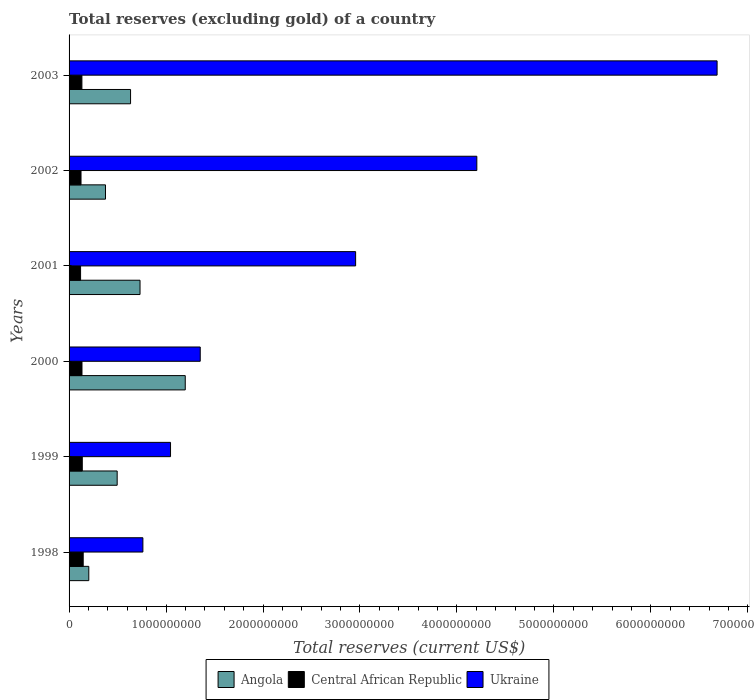How many different coloured bars are there?
Offer a very short reply. 3. How many groups of bars are there?
Your answer should be very brief. 6. Are the number of bars on each tick of the Y-axis equal?
Provide a short and direct response. Yes. How many bars are there on the 1st tick from the top?
Your answer should be very brief. 3. What is the label of the 4th group of bars from the top?
Your response must be concise. 2000. What is the total reserves (excluding gold) in Angola in 2002?
Make the answer very short. 3.76e+08. Across all years, what is the maximum total reserves (excluding gold) in Ukraine?
Ensure brevity in your answer.  6.68e+09. Across all years, what is the minimum total reserves (excluding gold) in Central African Republic?
Offer a terse response. 1.19e+08. In which year was the total reserves (excluding gold) in Angola minimum?
Keep it short and to the point. 1998. What is the total total reserves (excluding gold) in Angola in the graph?
Make the answer very short. 3.64e+09. What is the difference between the total reserves (excluding gold) in Central African Republic in 2001 and that in 2003?
Your answer should be very brief. -1.37e+07. What is the difference between the total reserves (excluding gold) in Central African Republic in 2000 and the total reserves (excluding gold) in Angola in 1999?
Offer a very short reply. -3.63e+08. What is the average total reserves (excluding gold) in Ukraine per year?
Provide a short and direct response. 2.83e+09. In the year 1998, what is the difference between the total reserves (excluding gold) in Ukraine and total reserves (excluding gold) in Central African Republic?
Provide a short and direct response. 6.16e+08. In how many years, is the total reserves (excluding gold) in Ukraine greater than 3800000000 US$?
Give a very brief answer. 2. What is the ratio of the total reserves (excluding gold) in Ukraine in 1999 to that in 2002?
Provide a succinct answer. 0.25. Is the total reserves (excluding gold) in Ukraine in 2000 less than that in 2002?
Keep it short and to the point. Yes. Is the difference between the total reserves (excluding gold) in Ukraine in 2000 and 2002 greater than the difference between the total reserves (excluding gold) in Central African Republic in 2000 and 2002?
Give a very brief answer. No. What is the difference between the highest and the second highest total reserves (excluding gold) in Angola?
Offer a terse response. 4.66e+08. What is the difference between the highest and the lowest total reserves (excluding gold) in Central African Republic?
Provide a short and direct response. 2.70e+07. Is the sum of the total reserves (excluding gold) in Ukraine in 1999 and 2003 greater than the maximum total reserves (excluding gold) in Central African Republic across all years?
Provide a succinct answer. Yes. What does the 3rd bar from the top in 1998 represents?
Offer a terse response. Angola. What does the 3rd bar from the bottom in 2000 represents?
Provide a short and direct response. Ukraine. Is it the case that in every year, the sum of the total reserves (excluding gold) in Ukraine and total reserves (excluding gold) in Central African Republic is greater than the total reserves (excluding gold) in Angola?
Provide a succinct answer. Yes. Are all the bars in the graph horizontal?
Provide a succinct answer. Yes. What is the difference between two consecutive major ticks on the X-axis?
Provide a succinct answer. 1.00e+09. Does the graph contain any zero values?
Provide a short and direct response. No. Does the graph contain grids?
Your response must be concise. No. Where does the legend appear in the graph?
Offer a terse response. Bottom center. How many legend labels are there?
Your response must be concise. 3. What is the title of the graph?
Give a very brief answer. Total reserves (excluding gold) of a country. Does "Libya" appear as one of the legend labels in the graph?
Your answer should be very brief. No. What is the label or title of the X-axis?
Keep it short and to the point. Total reserves (current US$). What is the Total reserves (current US$) of Angola in 1998?
Your answer should be very brief. 2.03e+08. What is the Total reserves (current US$) in Central African Republic in 1998?
Your answer should be very brief. 1.46e+08. What is the Total reserves (current US$) of Ukraine in 1998?
Provide a succinct answer. 7.61e+08. What is the Total reserves (current US$) in Angola in 1999?
Keep it short and to the point. 4.96e+08. What is the Total reserves (current US$) of Central African Republic in 1999?
Provide a short and direct response. 1.36e+08. What is the Total reserves (current US$) in Ukraine in 1999?
Ensure brevity in your answer.  1.05e+09. What is the Total reserves (current US$) in Angola in 2000?
Provide a succinct answer. 1.20e+09. What is the Total reserves (current US$) of Central African Republic in 2000?
Offer a very short reply. 1.33e+08. What is the Total reserves (current US$) in Ukraine in 2000?
Your answer should be very brief. 1.35e+09. What is the Total reserves (current US$) in Angola in 2001?
Ensure brevity in your answer.  7.32e+08. What is the Total reserves (current US$) of Central African Republic in 2001?
Your response must be concise. 1.19e+08. What is the Total reserves (current US$) in Ukraine in 2001?
Provide a short and direct response. 2.96e+09. What is the Total reserves (current US$) of Angola in 2002?
Your answer should be very brief. 3.76e+08. What is the Total reserves (current US$) in Central African Republic in 2002?
Keep it short and to the point. 1.23e+08. What is the Total reserves (current US$) of Ukraine in 2002?
Provide a succinct answer. 4.21e+09. What is the Total reserves (current US$) of Angola in 2003?
Your answer should be compact. 6.34e+08. What is the Total reserves (current US$) of Central African Republic in 2003?
Keep it short and to the point. 1.32e+08. What is the Total reserves (current US$) of Ukraine in 2003?
Keep it short and to the point. 6.68e+09. Across all years, what is the maximum Total reserves (current US$) in Angola?
Your answer should be very brief. 1.20e+09. Across all years, what is the maximum Total reserves (current US$) in Central African Republic?
Your answer should be very brief. 1.46e+08. Across all years, what is the maximum Total reserves (current US$) in Ukraine?
Ensure brevity in your answer.  6.68e+09. Across all years, what is the minimum Total reserves (current US$) of Angola?
Your answer should be very brief. 2.03e+08. Across all years, what is the minimum Total reserves (current US$) of Central African Republic?
Your response must be concise. 1.19e+08. Across all years, what is the minimum Total reserves (current US$) in Ukraine?
Give a very brief answer. 7.61e+08. What is the total Total reserves (current US$) in Angola in the graph?
Provide a succinct answer. 3.64e+09. What is the total Total reserves (current US$) in Central African Republic in the graph?
Your answer should be compact. 7.90e+08. What is the total Total reserves (current US$) in Ukraine in the graph?
Provide a succinct answer. 1.70e+1. What is the difference between the Total reserves (current US$) of Angola in 1998 and that in 1999?
Provide a short and direct response. -2.93e+08. What is the difference between the Total reserves (current US$) of Central African Republic in 1998 and that in 1999?
Make the answer very short. 9.42e+06. What is the difference between the Total reserves (current US$) of Ukraine in 1998 and that in 1999?
Offer a very short reply. -2.85e+08. What is the difference between the Total reserves (current US$) of Angola in 1998 and that in 2000?
Your answer should be compact. -9.95e+08. What is the difference between the Total reserves (current US$) of Central African Republic in 1998 and that in 2000?
Offer a terse response. 1.24e+07. What is the difference between the Total reserves (current US$) in Ukraine in 1998 and that in 2000?
Your answer should be compact. -5.91e+08. What is the difference between the Total reserves (current US$) in Angola in 1998 and that in 2001?
Your response must be concise. -5.28e+08. What is the difference between the Total reserves (current US$) of Central African Republic in 1998 and that in 2001?
Offer a terse response. 2.70e+07. What is the difference between the Total reserves (current US$) of Ukraine in 1998 and that in 2001?
Make the answer very short. -2.19e+09. What is the difference between the Total reserves (current US$) of Angola in 1998 and that in 2002?
Provide a succinct answer. -1.72e+08. What is the difference between the Total reserves (current US$) in Central African Republic in 1998 and that in 2002?
Offer a terse response. 2.25e+07. What is the difference between the Total reserves (current US$) in Ukraine in 1998 and that in 2002?
Keep it short and to the point. -3.44e+09. What is the difference between the Total reserves (current US$) in Angola in 1998 and that in 2003?
Ensure brevity in your answer.  -4.31e+08. What is the difference between the Total reserves (current US$) of Central African Republic in 1998 and that in 2003?
Make the answer very short. 1.33e+07. What is the difference between the Total reserves (current US$) of Ukraine in 1998 and that in 2003?
Your response must be concise. -5.92e+09. What is the difference between the Total reserves (current US$) of Angola in 1999 and that in 2000?
Give a very brief answer. -7.02e+08. What is the difference between the Total reserves (current US$) in Central African Republic in 1999 and that in 2000?
Your response must be concise. 3.02e+06. What is the difference between the Total reserves (current US$) in Ukraine in 1999 and that in 2000?
Offer a very short reply. -3.06e+08. What is the difference between the Total reserves (current US$) in Angola in 1999 and that in 2001?
Provide a short and direct response. -2.36e+08. What is the difference between the Total reserves (current US$) in Central African Republic in 1999 and that in 2001?
Give a very brief answer. 1.75e+07. What is the difference between the Total reserves (current US$) in Ukraine in 1999 and that in 2001?
Keep it short and to the point. -1.91e+09. What is the difference between the Total reserves (current US$) of Angola in 1999 and that in 2002?
Your answer should be compact. 1.21e+08. What is the difference between the Total reserves (current US$) in Central African Republic in 1999 and that in 2002?
Offer a very short reply. 1.30e+07. What is the difference between the Total reserves (current US$) in Ukraine in 1999 and that in 2002?
Keep it short and to the point. -3.16e+09. What is the difference between the Total reserves (current US$) of Angola in 1999 and that in 2003?
Provide a short and direct response. -1.38e+08. What is the difference between the Total reserves (current US$) in Central African Republic in 1999 and that in 2003?
Your answer should be very brief. 3.87e+06. What is the difference between the Total reserves (current US$) of Ukraine in 1999 and that in 2003?
Give a very brief answer. -5.64e+09. What is the difference between the Total reserves (current US$) of Angola in 2000 and that in 2001?
Ensure brevity in your answer.  4.66e+08. What is the difference between the Total reserves (current US$) in Central African Republic in 2000 and that in 2001?
Provide a succinct answer. 1.45e+07. What is the difference between the Total reserves (current US$) in Ukraine in 2000 and that in 2001?
Keep it short and to the point. -1.60e+09. What is the difference between the Total reserves (current US$) in Angola in 2000 and that in 2002?
Make the answer very short. 8.23e+08. What is the difference between the Total reserves (current US$) in Central African Republic in 2000 and that in 2002?
Your answer should be very brief. 1.00e+07. What is the difference between the Total reserves (current US$) in Ukraine in 2000 and that in 2002?
Keep it short and to the point. -2.85e+09. What is the difference between the Total reserves (current US$) of Angola in 2000 and that in 2003?
Ensure brevity in your answer.  5.64e+08. What is the difference between the Total reserves (current US$) in Central African Republic in 2000 and that in 2003?
Provide a short and direct response. 8.47e+05. What is the difference between the Total reserves (current US$) in Ukraine in 2000 and that in 2003?
Keep it short and to the point. -5.33e+09. What is the difference between the Total reserves (current US$) in Angola in 2001 and that in 2002?
Your answer should be very brief. 3.56e+08. What is the difference between the Total reserves (current US$) of Central African Republic in 2001 and that in 2002?
Make the answer very short. -4.49e+06. What is the difference between the Total reserves (current US$) in Ukraine in 2001 and that in 2002?
Your response must be concise. -1.25e+09. What is the difference between the Total reserves (current US$) of Angola in 2001 and that in 2003?
Give a very brief answer. 9.77e+07. What is the difference between the Total reserves (current US$) in Central African Republic in 2001 and that in 2003?
Give a very brief answer. -1.37e+07. What is the difference between the Total reserves (current US$) of Ukraine in 2001 and that in 2003?
Provide a short and direct response. -3.73e+09. What is the difference between the Total reserves (current US$) in Angola in 2002 and that in 2003?
Give a very brief answer. -2.59e+08. What is the difference between the Total reserves (current US$) in Central African Republic in 2002 and that in 2003?
Provide a succinct answer. -9.17e+06. What is the difference between the Total reserves (current US$) of Ukraine in 2002 and that in 2003?
Give a very brief answer. -2.48e+09. What is the difference between the Total reserves (current US$) of Angola in 1998 and the Total reserves (current US$) of Central African Republic in 1999?
Ensure brevity in your answer.  6.72e+07. What is the difference between the Total reserves (current US$) in Angola in 1998 and the Total reserves (current US$) in Ukraine in 1999?
Provide a succinct answer. -8.43e+08. What is the difference between the Total reserves (current US$) of Central African Republic in 1998 and the Total reserves (current US$) of Ukraine in 1999?
Offer a very short reply. -9.01e+08. What is the difference between the Total reserves (current US$) of Angola in 1998 and the Total reserves (current US$) of Central African Republic in 2000?
Give a very brief answer. 7.02e+07. What is the difference between the Total reserves (current US$) in Angola in 1998 and the Total reserves (current US$) in Ukraine in 2000?
Offer a very short reply. -1.15e+09. What is the difference between the Total reserves (current US$) of Central African Republic in 1998 and the Total reserves (current US$) of Ukraine in 2000?
Make the answer very short. -1.21e+09. What is the difference between the Total reserves (current US$) of Angola in 1998 and the Total reserves (current US$) of Central African Republic in 2001?
Your answer should be very brief. 8.47e+07. What is the difference between the Total reserves (current US$) of Angola in 1998 and the Total reserves (current US$) of Ukraine in 2001?
Ensure brevity in your answer.  -2.75e+09. What is the difference between the Total reserves (current US$) of Central African Republic in 1998 and the Total reserves (current US$) of Ukraine in 2001?
Make the answer very short. -2.81e+09. What is the difference between the Total reserves (current US$) of Angola in 1998 and the Total reserves (current US$) of Central African Republic in 2002?
Make the answer very short. 8.02e+07. What is the difference between the Total reserves (current US$) in Angola in 1998 and the Total reserves (current US$) in Ukraine in 2002?
Offer a terse response. -4.00e+09. What is the difference between the Total reserves (current US$) of Central African Republic in 1998 and the Total reserves (current US$) of Ukraine in 2002?
Offer a terse response. -4.06e+09. What is the difference between the Total reserves (current US$) of Angola in 1998 and the Total reserves (current US$) of Central African Republic in 2003?
Give a very brief answer. 7.10e+07. What is the difference between the Total reserves (current US$) in Angola in 1998 and the Total reserves (current US$) in Ukraine in 2003?
Give a very brief answer. -6.48e+09. What is the difference between the Total reserves (current US$) of Central African Republic in 1998 and the Total reserves (current US$) of Ukraine in 2003?
Provide a succinct answer. -6.54e+09. What is the difference between the Total reserves (current US$) in Angola in 1999 and the Total reserves (current US$) in Central African Republic in 2000?
Your response must be concise. 3.63e+08. What is the difference between the Total reserves (current US$) of Angola in 1999 and the Total reserves (current US$) of Ukraine in 2000?
Your answer should be very brief. -8.57e+08. What is the difference between the Total reserves (current US$) in Central African Republic in 1999 and the Total reserves (current US$) in Ukraine in 2000?
Keep it short and to the point. -1.22e+09. What is the difference between the Total reserves (current US$) in Angola in 1999 and the Total reserves (current US$) in Central African Republic in 2001?
Give a very brief answer. 3.77e+08. What is the difference between the Total reserves (current US$) in Angola in 1999 and the Total reserves (current US$) in Ukraine in 2001?
Give a very brief answer. -2.46e+09. What is the difference between the Total reserves (current US$) of Central African Republic in 1999 and the Total reserves (current US$) of Ukraine in 2001?
Your answer should be compact. -2.82e+09. What is the difference between the Total reserves (current US$) in Angola in 1999 and the Total reserves (current US$) in Central African Republic in 2002?
Your answer should be very brief. 3.73e+08. What is the difference between the Total reserves (current US$) in Angola in 1999 and the Total reserves (current US$) in Ukraine in 2002?
Offer a terse response. -3.71e+09. What is the difference between the Total reserves (current US$) in Central African Republic in 1999 and the Total reserves (current US$) in Ukraine in 2002?
Ensure brevity in your answer.  -4.07e+09. What is the difference between the Total reserves (current US$) of Angola in 1999 and the Total reserves (current US$) of Central African Republic in 2003?
Your answer should be very brief. 3.64e+08. What is the difference between the Total reserves (current US$) of Angola in 1999 and the Total reserves (current US$) of Ukraine in 2003?
Keep it short and to the point. -6.19e+09. What is the difference between the Total reserves (current US$) in Central African Republic in 1999 and the Total reserves (current US$) in Ukraine in 2003?
Provide a short and direct response. -6.55e+09. What is the difference between the Total reserves (current US$) in Angola in 2000 and the Total reserves (current US$) in Central African Republic in 2001?
Your answer should be very brief. 1.08e+09. What is the difference between the Total reserves (current US$) of Angola in 2000 and the Total reserves (current US$) of Ukraine in 2001?
Your response must be concise. -1.76e+09. What is the difference between the Total reserves (current US$) in Central African Republic in 2000 and the Total reserves (current US$) in Ukraine in 2001?
Your answer should be compact. -2.82e+09. What is the difference between the Total reserves (current US$) of Angola in 2000 and the Total reserves (current US$) of Central African Republic in 2002?
Offer a terse response. 1.07e+09. What is the difference between the Total reserves (current US$) in Angola in 2000 and the Total reserves (current US$) in Ukraine in 2002?
Keep it short and to the point. -3.01e+09. What is the difference between the Total reserves (current US$) of Central African Republic in 2000 and the Total reserves (current US$) of Ukraine in 2002?
Offer a terse response. -4.07e+09. What is the difference between the Total reserves (current US$) in Angola in 2000 and the Total reserves (current US$) in Central African Republic in 2003?
Give a very brief answer. 1.07e+09. What is the difference between the Total reserves (current US$) in Angola in 2000 and the Total reserves (current US$) in Ukraine in 2003?
Your response must be concise. -5.48e+09. What is the difference between the Total reserves (current US$) in Central African Republic in 2000 and the Total reserves (current US$) in Ukraine in 2003?
Your answer should be very brief. -6.55e+09. What is the difference between the Total reserves (current US$) in Angola in 2001 and the Total reserves (current US$) in Central African Republic in 2002?
Offer a very short reply. 6.09e+08. What is the difference between the Total reserves (current US$) of Angola in 2001 and the Total reserves (current US$) of Ukraine in 2002?
Ensure brevity in your answer.  -3.47e+09. What is the difference between the Total reserves (current US$) of Central African Republic in 2001 and the Total reserves (current US$) of Ukraine in 2002?
Keep it short and to the point. -4.09e+09. What is the difference between the Total reserves (current US$) of Angola in 2001 and the Total reserves (current US$) of Central African Republic in 2003?
Make the answer very short. 5.99e+08. What is the difference between the Total reserves (current US$) in Angola in 2001 and the Total reserves (current US$) in Ukraine in 2003?
Provide a succinct answer. -5.95e+09. What is the difference between the Total reserves (current US$) of Central African Republic in 2001 and the Total reserves (current US$) of Ukraine in 2003?
Make the answer very short. -6.56e+09. What is the difference between the Total reserves (current US$) of Angola in 2002 and the Total reserves (current US$) of Central African Republic in 2003?
Your answer should be very brief. 2.43e+08. What is the difference between the Total reserves (current US$) in Angola in 2002 and the Total reserves (current US$) in Ukraine in 2003?
Make the answer very short. -6.31e+09. What is the difference between the Total reserves (current US$) of Central African Republic in 2002 and the Total reserves (current US$) of Ukraine in 2003?
Your response must be concise. -6.56e+09. What is the average Total reserves (current US$) in Angola per year?
Offer a terse response. 6.07e+08. What is the average Total reserves (current US$) of Central African Republic per year?
Your response must be concise. 1.32e+08. What is the average Total reserves (current US$) in Ukraine per year?
Your answer should be very brief. 2.83e+09. In the year 1998, what is the difference between the Total reserves (current US$) of Angola and Total reserves (current US$) of Central African Republic?
Offer a very short reply. 5.78e+07. In the year 1998, what is the difference between the Total reserves (current US$) of Angola and Total reserves (current US$) of Ukraine?
Make the answer very short. -5.58e+08. In the year 1998, what is the difference between the Total reserves (current US$) in Central African Republic and Total reserves (current US$) in Ukraine?
Your answer should be compact. -6.16e+08. In the year 1999, what is the difference between the Total reserves (current US$) in Angola and Total reserves (current US$) in Central African Republic?
Provide a succinct answer. 3.60e+08. In the year 1999, what is the difference between the Total reserves (current US$) in Angola and Total reserves (current US$) in Ukraine?
Provide a short and direct response. -5.50e+08. In the year 1999, what is the difference between the Total reserves (current US$) of Central African Republic and Total reserves (current US$) of Ukraine?
Your answer should be very brief. -9.10e+08. In the year 2000, what is the difference between the Total reserves (current US$) in Angola and Total reserves (current US$) in Central African Republic?
Offer a very short reply. 1.06e+09. In the year 2000, what is the difference between the Total reserves (current US$) of Angola and Total reserves (current US$) of Ukraine?
Offer a very short reply. -1.54e+08. In the year 2000, what is the difference between the Total reserves (current US$) of Central African Republic and Total reserves (current US$) of Ukraine?
Your response must be concise. -1.22e+09. In the year 2001, what is the difference between the Total reserves (current US$) of Angola and Total reserves (current US$) of Central African Republic?
Keep it short and to the point. 6.13e+08. In the year 2001, what is the difference between the Total reserves (current US$) in Angola and Total reserves (current US$) in Ukraine?
Provide a succinct answer. -2.22e+09. In the year 2001, what is the difference between the Total reserves (current US$) of Central African Republic and Total reserves (current US$) of Ukraine?
Provide a succinct answer. -2.84e+09. In the year 2002, what is the difference between the Total reserves (current US$) in Angola and Total reserves (current US$) in Central African Republic?
Provide a succinct answer. 2.52e+08. In the year 2002, what is the difference between the Total reserves (current US$) of Angola and Total reserves (current US$) of Ukraine?
Give a very brief answer. -3.83e+09. In the year 2002, what is the difference between the Total reserves (current US$) of Central African Republic and Total reserves (current US$) of Ukraine?
Provide a succinct answer. -4.08e+09. In the year 2003, what is the difference between the Total reserves (current US$) in Angola and Total reserves (current US$) in Central African Republic?
Offer a terse response. 5.02e+08. In the year 2003, what is the difference between the Total reserves (current US$) in Angola and Total reserves (current US$) in Ukraine?
Offer a very short reply. -6.05e+09. In the year 2003, what is the difference between the Total reserves (current US$) of Central African Republic and Total reserves (current US$) of Ukraine?
Ensure brevity in your answer.  -6.55e+09. What is the ratio of the Total reserves (current US$) in Angola in 1998 to that in 1999?
Your response must be concise. 0.41. What is the ratio of the Total reserves (current US$) of Central African Republic in 1998 to that in 1999?
Ensure brevity in your answer.  1.07. What is the ratio of the Total reserves (current US$) of Ukraine in 1998 to that in 1999?
Your response must be concise. 0.73. What is the ratio of the Total reserves (current US$) in Angola in 1998 to that in 2000?
Provide a succinct answer. 0.17. What is the ratio of the Total reserves (current US$) in Central African Republic in 1998 to that in 2000?
Provide a short and direct response. 1.09. What is the ratio of the Total reserves (current US$) in Ukraine in 1998 to that in 2000?
Offer a terse response. 0.56. What is the ratio of the Total reserves (current US$) of Angola in 1998 to that in 2001?
Ensure brevity in your answer.  0.28. What is the ratio of the Total reserves (current US$) of Central African Republic in 1998 to that in 2001?
Your answer should be very brief. 1.23. What is the ratio of the Total reserves (current US$) in Ukraine in 1998 to that in 2001?
Keep it short and to the point. 0.26. What is the ratio of the Total reserves (current US$) of Angola in 1998 to that in 2002?
Provide a succinct answer. 0.54. What is the ratio of the Total reserves (current US$) of Central African Republic in 1998 to that in 2002?
Your response must be concise. 1.18. What is the ratio of the Total reserves (current US$) of Ukraine in 1998 to that in 2002?
Keep it short and to the point. 0.18. What is the ratio of the Total reserves (current US$) of Angola in 1998 to that in 2003?
Provide a succinct answer. 0.32. What is the ratio of the Total reserves (current US$) in Central African Republic in 1998 to that in 2003?
Give a very brief answer. 1.1. What is the ratio of the Total reserves (current US$) of Ukraine in 1998 to that in 2003?
Ensure brevity in your answer.  0.11. What is the ratio of the Total reserves (current US$) in Angola in 1999 to that in 2000?
Your response must be concise. 0.41. What is the ratio of the Total reserves (current US$) in Central African Republic in 1999 to that in 2000?
Offer a very short reply. 1.02. What is the ratio of the Total reserves (current US$) of Ukraine in 1999 to that in 2000?
Make the answer very short. 0.77. What is the ratio of the Total reserves (current US$) of Angola in 1999 to that in 2001?
Provide a short and direct response. 0.68. What is the ratio of the Total reserves (current US$) of Central African Republic in 1999 to that in 2001?
Give a very brief answer. 1.15. What is the ratio of the Total reserves (current US$) in Ukraine in 1999 to that in 2001?
Your answer should be compact. 0.35. What is the ratio of the Total reserves (current US$) in Angola in 1999 to that in 2002?
Ensure brevity in your answer.  1.32. What is the ratio of the Total reserves (current US$) in Central African Republic in 1999 to that in 2002?
Your answer should be very brief. 1.11. What is the ratio of the Total reserves (current US$) of Ukraine in 1999 to that in 2002?
Your answer should be compact. 0.25. What is the ratio of the Total reserves (current US$) of Angola in 1999 to that in 2003?
Offer a very short reply. 0.78. What is the ratio of the Total reserves (current US$) in Central African Republic in 1999 to that in 2003?
Your answer should be very brief. 1.03. What is the ratio of the Total reserves (current US$) in Ukraine in 1999 to that in 2003?
Ensure brevity in your answer.  0.16. What is the ratio of the Total reserves (current US$) of Angola in 2000 to that in 2001?
Give a very brief answer. 1.64. What is the ratio of the Total reserves (current US$) in Central African Republic in 2000 to that in 2001?
Your response must be concise. 1.12. What is the ratio of the Total reserves (current US$) in Ukraine in 2000 to that in 2001?
Give a very brief answer. 0.46. What is the ratio of the Total reserves (current US$) of Angola in 2000 to that in 2002?
Make the answer very short. 3.19. What is the ratio of the Total reserves (current US$) of Central African Republic in 2000 to that in 2002?
Keep it short and to the point. 1.08. What is the ratio of the Total reserves (current US$) in Ukraine in 2000 to that in 2002?
Offer a terse response. 0.32. What is the ratio of the Total reserves (current US$) in Angola in 2000 to that in 2003?
Offer a very short reply. 1.89. What is the ratio of the Total reserves (current US$) in Central African Republic in 2000 to that in 2003?
Give a very brief answer. 1.01. What is the ratio of the Total reserves (current US$) of Ukraine in 2000 to that in 2003?
Provide a short and direct response. 0.2. What is the ratio of the Total reserves (current US$) of Angola in 2001 to that in 2002?
Ensure brevity in your answer.  1.95. What is the ratio of the Total reserves (current US$) of Central African Republic in 2001 to that in 2002?
Keep it short and to the point. 0.96. What is the ratio of the Total reserves (current US$) in Ukraine in 2001 to that in 2002?
Ensure brevity in your answer.  0.7. What is the ratio of the Total reserves (current US$) in Angola in 2001 to that in 2003?
Ensure brevity in your answer.  1.15. What is the ratio of the Total reserves (current US$) of Central African Republic in 2001 to that in 2003?
Your answer should be compact. 0.9. What is the ratio of the Total reserves (current US$) in Ukraine in 2001 to that in 2003?
Your response must be concise. 0.44. What is the ratio of the Total reserves (current US$) of Angola in 2002 to that in 2003?
Provide a succinct answer. 0.59. What is the ratio of the Total reserves (current US$) in Central African Republic in 2002 to that in 2003?
Your response must be concise. 0.93. What is the ratio of the Total reserves (current US$) in Ukraine in 2002 to that in 2003?
Provide a short and direct response. 0.63. What is the difference between the highest and the second highest Total reserves (current US$) in Angola?
Your answer should be compact. 4.66e+08. What is the difference between the highest and the second highest Total reserves (current US$) in Central African Republic?
Make the answer very short. 9.42e+06. What is the difference between the highest and the second highest Total reserves (current US$) in Ukraine?
Ensure brevity in your answer.  2.48e+09. What is the difference between the highest and the lowest Total reserves (current US$) of Angola?
Offer a very short reply. 9.95e+08. What is the difference between the highest and the lowest Total reserves (current US$) of Central African Republic?
Provide a succinct answer. 2.70e+07. What is the difference between the highest and the lowest Total reserves (current US$) in Ukraine?
Provide a short and direct response. 5.92e+09. 